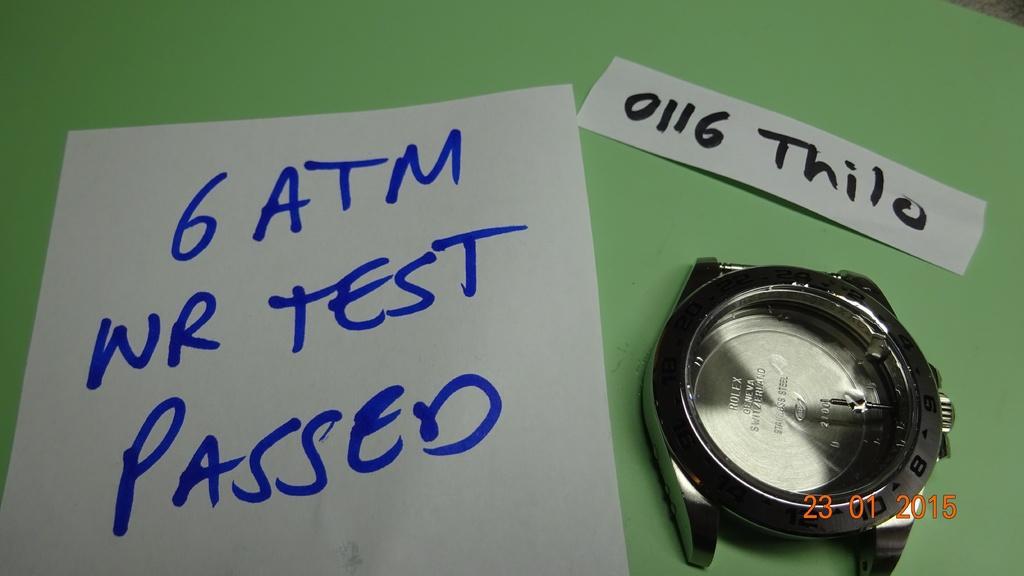Describe this image in one or two sentences. In this image I can see two pages and a watch are placed on a table. On the papers there is some text. 